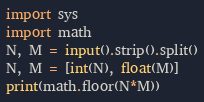Convert code to text. <code><loc_0><loc_0><loc_500><loc_500><_Python_>import sys
import math
N, M = input().strip().split()
N, M = [int(N), float(M)]
print(math.floor(N*M))</code> 